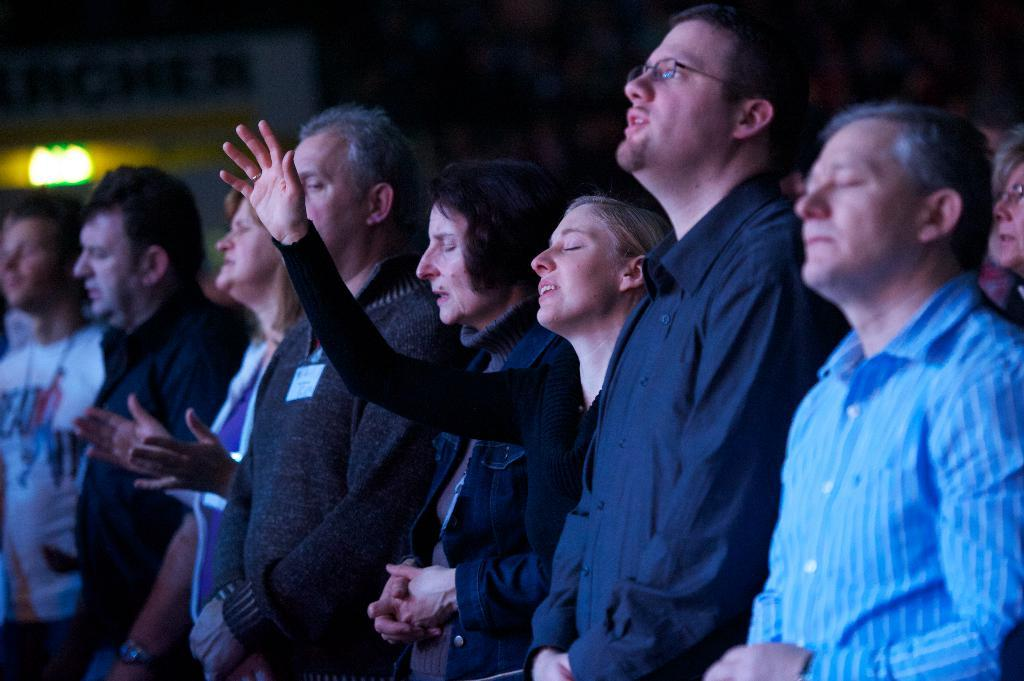How many people are in the image? There is a group of people in the image, but the exact number is not specified. What can be seen in the image besides the people? There is a light in the image. What is the color of the background in the image? The background of the image is dark. What type of spoon is being used to make a statement in the image? There is no spoon or statement being made in the image. 